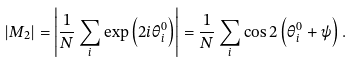<formula> <loc_0><loc_0><loc_500><loc_500>| M _ { 2 } | = \left | \frac { 1 } { N } \sum _ { i } \exp \left ( 2 i \theta _ { i } ^ { 0 } \right ) \right | = \frac { 1 } { N } \sum _ { i } \cos 2 \left ( \theta _ { i } ^ { 0 } + \psi \right ) .</formula> 